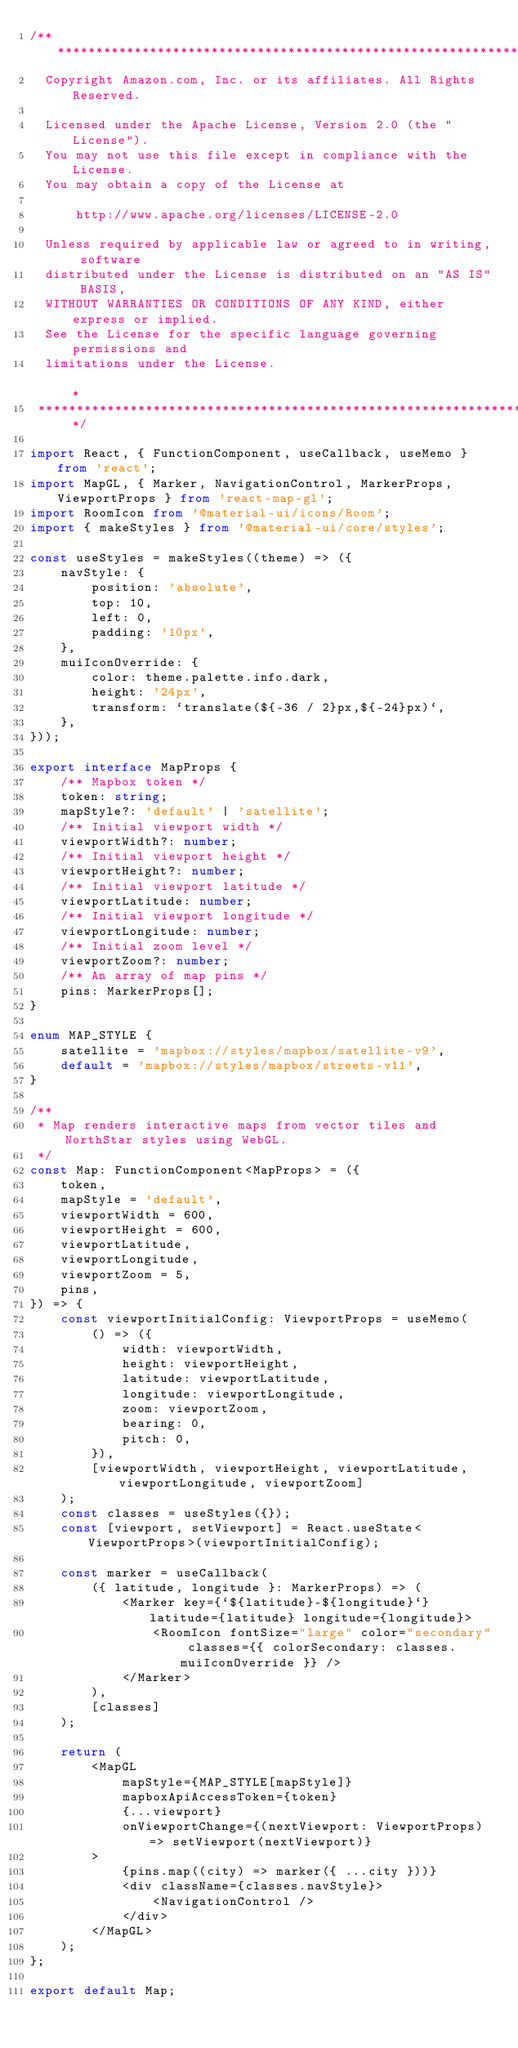<code> <loc_0><loc_0><loc_500><loc_500><_TypeScript_>/** *******************************************************************************************************************
  Copyright Amazon.com, Inc. or its affiliates. All Rights Reserved.
  
  Licensed under the Apache License, Version 2.0 (the "License").
  You may not use this file except in compliance with the License.
  You may obtain a copy of the License at
  
      http://www.apache.org/licenses/LICENSE-2.0
  
  Unless required by applicable law or agreed to in writing, software
  distributed under the License is distributed on an "AS IS" BASIS,
  WITHOUT WARRANTIES OR CONDITIONS OF ANY KIND, either express or implied.
  See the License for the specific language governing permissions and
  limitations under the License.                                                                              *
 ******************************************************************************************************************** */

import React, { FunctionComponent, useCallback, useMemo } from 'react';
import MapGL, { Marker, NavigationControl, MarkerProps, ViewportProps } from 'react-map-gl';
import RoomIcon from '@material-ui/icons/Room';
import { makeStyles } from '@material-ui/core/styles';

const useStyles = makeStyles((theme) => ({
    navStyle: {
        position: 'absolute',
        top: 10,
        left: 0,
        padding: '10px',
    },
    muiIconOverride: {
        color: theme.palette.info.dark,
        height: '24px',
        transform: `translate(${-36 / 2}px,${-24}px)`,
    },
}));

export interface MapProps {
    /** Mapbox token */
    token: string;
    mapStyle?: 'default' | 'satellite';
    /** Initial viewport width */
    viewportWidth?: number;
    /** Initial viewport height */
    viewportHeight?: number;
    /** Initial viewport latitude */
    viewportLatitude: number;
    /** Initial viewport longitude */
    viewportLongitude: number;
    /** Initial zoom level */
    viewportZoom?: number;
    /** An array of map pins */
    pins: MarkerProps[];
}

enum MAP_STYLE {
    satellite = 'mapbox://styles/mapbox/satellite-v9',
    default = 'mapbox://styles/mapbox/streets-v11',
}

/**
 * Map renders interactive maps from vector tiles and NorthStar styles using WebGL.
 */
const Map: FunctionComponent<MapProps> = ({
    token,
    mapStyle = 'default',
    viewportWidth = 600,
    viewportHeight = 600,
    viewportLatitude,
    viewportLongitude,
    viewportZoom = 5,
    pins,
}) => {
    const viewportInitialConfig: ViewportProps = useMemo(
        () => ({
            width: viewportWidth,
            height: viewportHeight,
            latitude: viewportLatitude,
            longitude: viewportLongitude,
            zoom: viewportZoom,
            bearing: 0,
            pitch: 0,
        }),
        [viewportWidth, viewportHeight, viewportLatitude, viewportLongitude, viewportZoom]
    );
    const classes = useStyles({});
    const [viewport, setViewport] = React.useState<ViewportProps>(viewportInitialConfig);

    const marker = useCallback(
        ({ latitude, longitude }: MarkerProps) => (
            <Marker key={`${latitude}-${longitude}`} latitude={latitude} longitude={longitude}>
                <RoomIcon fontSize="large" color="secondary" classes={{ colorSecondary: classes.muiIconOverride }} />
            </Marker>
        ),
        [classes]
    );

    return (
        <MapGL
            mapStyle={MAP_STYLE[mapStyle]}
            mapboxApiAccessToken={token}
            {...viewport}
            onViewportChange={(nextViewport: ViewportProps) => setViewport(nextViewport)}
        >
            {pins.map((city) => marker({ ...city }))}
            <div className={classes.navStyle}>
                <NavigationControl />
            </div>
        </MapGL>
    );
};

export default Map;
</code> 